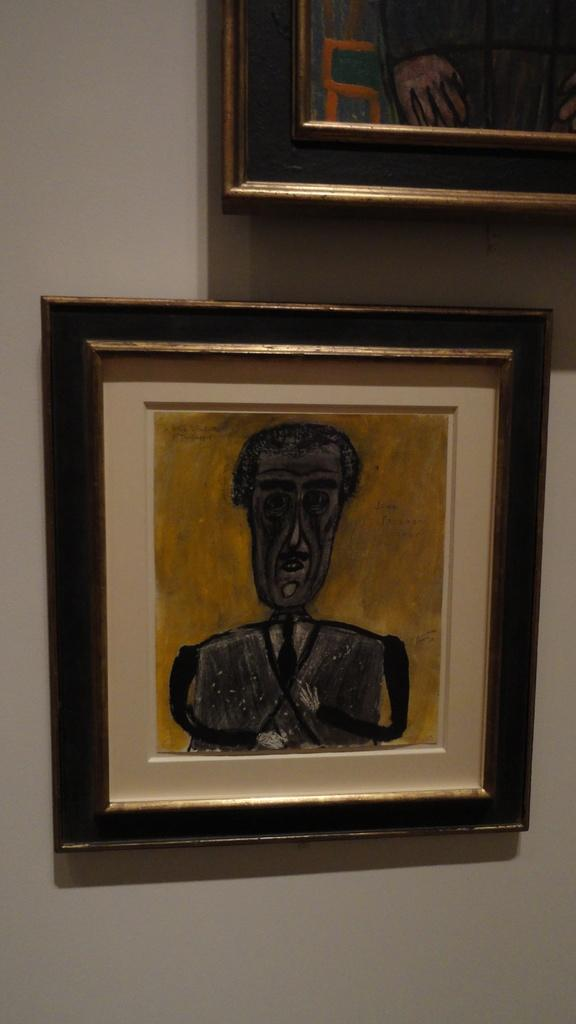What is present on the wall in the image? There are two frames on the wall in the image. How many bottles are visible in the image? There are no bottles present in the image. Is there a lift in the image? There is no lift present in the image. 